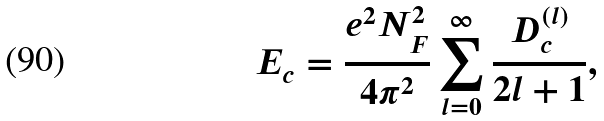Convert formula to latex. <formula><loc_0><loc_0><loc_500><loc_500>E _ { c } = \frac { e ^ { 2 } N _ { F } ^ { 2 } } { 4 \pi ^ { 2 } } \sum _ { l = 0 } ^ { \infty } \frac { D _ { c } ^ { ( l ) } } { 2 l + 1 } ,</formula> 